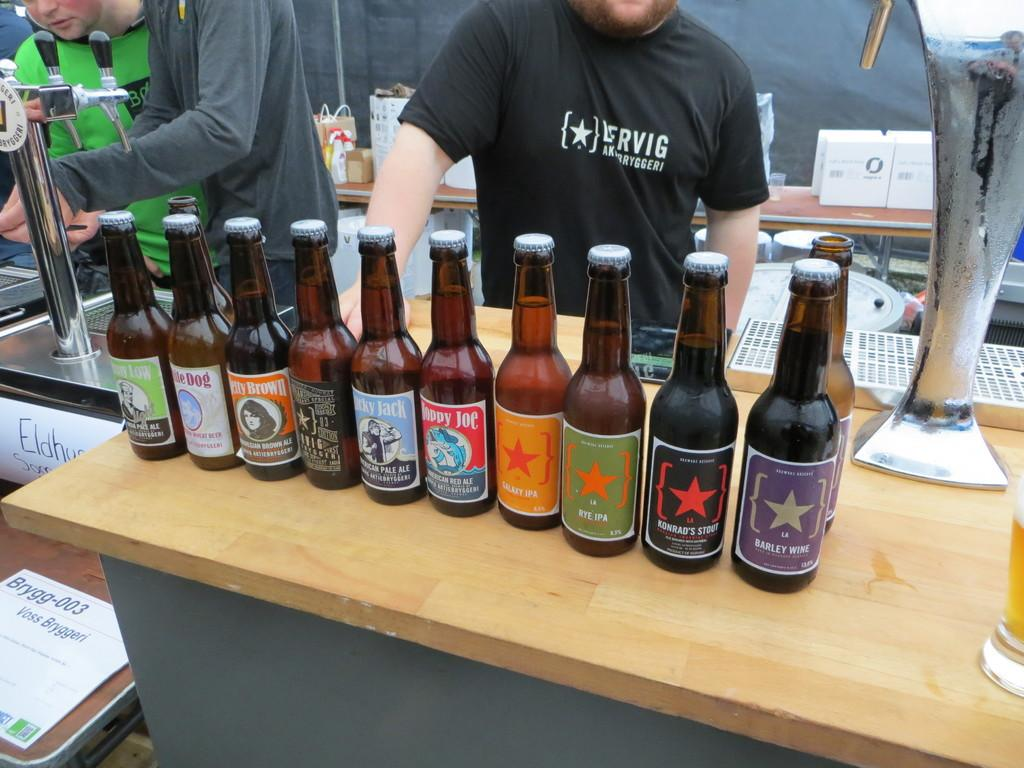<image>
Describe the image concisely. A row of lesser known beer brands include varieties such as Konrad's Stout and Barley Wine. 